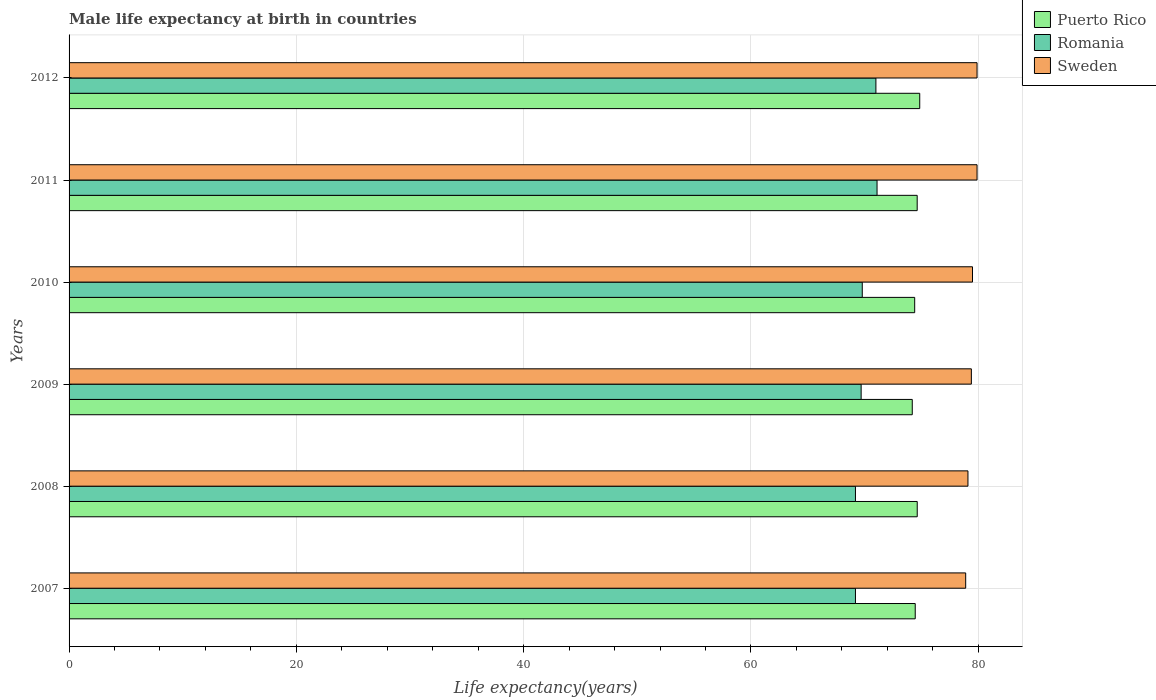In how many cases, is the number of bars for a given year not equal to the number of legend labels?
Make the answer very short. 0. What is the male life expectancy at birth in Puerto Rico in 2009?
Your response must be concise. 74.2. Across all years, what is the maximum male life expectancy at birth in Puerto Rico?
Your response must be concise. 74.86. Across all years, what is the minimum male life expectancy at birth in Sweden?
Your answer should be very brief. 78.9. In which year was the male life expectancy at birth in Romania minimum?
Provide a succinct answer. 2007. What is the total male life expectancy at birth in Puerto Rico in the graph?
Provide a short and direct response. 447.2. What is the difference between the male life expectancy at birth in Puerto Rico in 2009 and that in 2010?
Offer a very short reply. -0.21. What is the difference between the male life expectancy at birth in Puerto Rico in 2009 and the male life expectancy at birth in Sweden in 2012?
Offer a terse response. -5.7. What is the average male life expectancy at birth in Puerto Rico per year?
Your answer should be very brief. 74.53. In the year 2012, what is the difference between the male life expectancy at birth in Romania and male life expectancy at birth in Puerto Rico?
Your answer should be compact. -3.86. In how many years, is the male life expectancy at birth in Sweden greater than 48 years?
Provide a short and direct response. 6. What is the ratio of the male life expectancy at birth in Romania in 2007 to that in 2012?
Offer a very short reply. 0.97. What is the difference between the highest and the second highest male life expectancy at birth in Romania?
Your answer should be very brief. 0.1. What is the difference between the highest and the lowest male life expectancy at birth in Romania?
Give a very brief answer. 1.9. In how many years, is the male life expectancy at birth in Puerto Rico greater than the average male life expectancy at birth in Puerto Rico taken over all years?
Your answer should be compact. 3. What does the 3rd bar from the top in 2008 represents?
Offer a very short reply. Puerto Rico. What does the 1st bar from the bottom in 2011 represents?
Keep it short and to the point. Puerto Rico. Are all the bars in the graph horizontal?
Your answer should be very brief. Yes. How many years are there in the graph?
Your answer should be very brief. 6. What is the difference between two consecutive major ticks on the X-axis?
Your answer should be compact. 20. Does the graph contain any zero values?
Provide a succinct answer. No. Does the graph contain grids?
Offer a very short reply. Yes. How many legend labels are there?
Provide a short and direct response. 3. What is the title of the graph?
Your response must be concise. Male life expectancy at birth in countries. Does "Panama" appear as one of the legend labels in the graph?
Ensure brevity in your answer.  No. What is the label or title of the X-axis?
Provide a succinct answer. Life expectancy(years). What is the Life expectancy(years) of Puerto Rico in 2007?
Offer a very short reply. 74.46. What is the Life expectancy(years) of Romania in 2007?
Your answer should be compact. 69.2. What is the Life expectancy(years) in Sweden in 2007?
Make the answer very short. 78.9. What is the Life expectancy(years) in Puerto Rico in 2008?
Offer a terse response. 74.64. What is the Life expectancy(years) of Romania in 2008?
Offer a terse response. 69.2. What is the Life expectancy(years) in Sweden in 2008?
Make the answer very short. 79.1. What is the Life expectancy(years) in Puerto Rico in 2009?
Give a very brief answer. 74.2. What is the Life expectancy(years) in Romania in 2009?
Ensure brevity in your answer.  69.7. What is the Life expectancy(years) in Sweden in 2009?
Provide a short and direct response. 79.4. What is the Life expectancy(years) of Puerto Rico in 2010?
Provide a succinct answer. 74.41. What is the Life expectancy(years) in Romania in 2010?
Keep it short and to the point. 69.8. What is the Life expectancy(years) of Sweden in 2010?
Offer a very short reply. 79.5. What is the Life expectancy(years) in Puerto Rico in 2011?
Your response must be concise. 74.63. What is the Life expectancy(years) in Romania in 2011?
Your answer should be compact. 71.1. What is the Life expectancy(years) in Sweden in 2011?
Your response must be concise. 79.9. What is the Life expectancy(years) in Puerto Rico in 2012?
Provide a succinct answer. 74.86. What is the Life expectancy(years) of Sweden in 2012?
Your response must be concise. 79.9. Across all years, what is the maximum Life expectancy(years) in Puerto Rico?
Your answer should be very brief. 74.86. Across all years, what is the maximum Life expectancy(years) in Romania?
Your response must be concise. 71.1. Across all years, what is the maximum Life expectancy(years) of Sweden?
Your answer should be very brief. 79.9. Across all years, what is the minimum Life expectancy(years) of Puerto Rico?
Offer a terse response. 74.2. Across all years, what is the minimum Life expectancy(years) in Romania?
Offer a terse response. 69.2. Across all years, what is the minimum Life expectancy(years) of Sweden?
Make the answer very short. 78.9. What is the total Life expectancy(years) of Puerto Rico in the graph?
Your response must be concise. 447.2. What is the total Life expectancy(years) in Romania in the graph?
Provide a succinct answer. 420. What is the total Life expectancy(years) in Sweden in the graph?
Your answer should be compact. 476.7. What is the difference between the Life expectancy(years) in Puerto Rico in 2007 and that in 2008?
Give a very brief answer. -0.18. What is the difference between the Life expectancy(years) of Sweden in 2007 and that in 2008?
Your answer should be very brief. -0.2. What is the difference between the Life expectancy(years) of Puerto Rico in 2007 and that in 2009?
Keep it short and to the point. 0.26. What is the difference between the Life expectancy(years) in Romania in 2007 and that in 2009?
Your answer should be very brief. -0.5. What is the difference between the Life expectancy(years) in Sweden in 2007 and that in 2009?
Your answer should be very brief. -0.5. What is the difference between the Life expectancy(years) in Puerto Rico in 2007 and that in 2010?
Provide a succinct answer. 0.05. What is the difference between the Life expectancy(years) of Romania in 2007 and that in 2010?
Give a very brief answer. -0.6. What is the difference between the Life expectancy(years) in Puerto Rico in 2007 and that in 2011?
Offer a terse response. -0.17. What is the difference between the Life expectancy(years) in Sweden in 2007 and that in 2011?
Make the answer very short. -1. What is the difference between the Life expectancy(years) in Puerto Rico in 2007 and that in 2012?
Your response must be concise. -0.4. What is the difference between the Life expectancy(years) in Sweden in 2007 and that in 2012?
Give a very brief answer. -1. What is the difference between the Life expectancy(years) in Puerto Rico in 2008 and that in 2009?
Ensure brevity in your answer.  0.44. What is the difference between the Life expectancy(years) of Sweden in 2008 and that in 2009?
Your response must be concise. -0.3. What is the difference between the Life expectancy(years) of Puerto Rico in 2008 and that in 2010?
Your answer should be compact. 0.22. What is the difference between the Life expectancy(years) of Romania in 2008 and that in 2010?
Give a very brief answer. -0.6. What is the difference between the Life expectancy(years) of Sweden in 2008 and that in 2010?
Give a very brief answer. -0.4. What is the difference between the Life expectancy(years) of Puerto Rico in 2008 and that in 2011?
Ensure brevity in your answer.  0. What is the difference between the Life expectancy(years) in Puerto Rico in 2008 and that in 2012?
Ensure brevity in your answer.  -0.22. What is the difference between the Life expectancy(years) in Romania in 2008 and that in 2012?
Make the answer very short. -1.8. What is the difference between the Life expectancy(years) of Sweden in 2008 and that in 2012?
Offer a terse response. -0.8. What is the difference between the Life expectancy(years) in Puerto Rico in 2009 and that in 2010?
Offer a very short reply. -0.21. What is the difference between the Life expectancy(years) of Puerto Rico in 2009 and that in 2011?
Your answer should be compact. -0.43. What is the difference between the Life expectancy(years) in Sweden in 2009 and that in 2011?
Provide a succinct answer. -0.5. What is the difference between the Life expectancy(years) in Puerto Rico in 2009 and that in 2012?
Ensure brevity in your answer.  -0.66. What is the difference between the Life expectancy(years) of Romania in 2009 and that in 2012?
Provide a succinct answer. -1.3. What is the difference between the Life expectancy(years) of Sweden in 2009 and that in 2012?
Your response must be concise. -0.5. What is the difference between the Life expectancy(years) in Puerto Rico in 2010 and that in 2011?
Offer a terse response. -0.22. What is the difference between the Life expectancy(years) in Romania in 2010 and that in 2011?
Make the answer very short. -1.3. What is the difference between the Life expectancy(years) of Sweden in 2010 and that in 2011?
Ensure brevity in your answer.  -0.4. What is the difference between the Life expectancy(years) of Puerto Rico in 2010 and that in 2012?
Provide a short and direct response. -0.45. What is the difference between the Life expectancy(years) of Romania in 2010 and that in 2012?
Keep it short and to the point. -1.2. What is the difference between the Life expectancy(years) of Puerto Rico in 2011 and that in 2012?
Ensure brevity in your answer.  -0.22. What is the difference between the Life expectancy(years) of Romania in 2011 and that in 2012?
Your answer should be compact. 0.1. What is the difference between the Life expectancy(years) in Puerto Rico in 2007 and the Life expectancy(years) in Romania in 2008?
Keep it short and to the point. 5.26. What is the difference between the Life expectancy(years) of Puerto Rico in 2007 and the Life expectancy(years) of Sweden in 2008?
Provide a succinct answer. -4.64. What is the difference between the Life expectancy(years) in Puerto Rico in 2007 and the Life expectancy(years) in Romania in 2009?
Give a very brief answer. 4.76. What is the difference between the Life expectancy(years) in Puerto Rico in 2007 and the Life expectancy(years) in Sweden in 2009?
Your answer should be compact. -4.94. What is the difference between the Life expectancy(years) in Puerto Rico in 2007 and the Life expectancy(years) in Romania in 2010?
Offer a very short reply. 4.66. What is the difference between the Life expectancy(years) of Puerto Rico in 2007 and the Life expectancy(years) of Sweden in 2010?
Offer a terse response. -5.04. What is the difference between the Life expectancy(years) in Puerto Rico in 2007 and the Life expectancy(years) in Romania in 2011?
Offer a terse response. 3.36. What is the difference between the Life expectancy(years) in Puerto Rico in 2007 and the Life expectancy(years) in Sweden in 2011?
Give a very brief answer. -5.44. What is the difference between the Life expectancy(years) in Romania in 2007 and the Life expectancy(years) in Sweden in 2011?
Offer a very short reply. -10.7. What is the difference between the Life expectancy(years) in Puerto Rico in 2007 and the Life expectancy(years) in Romania in 2012?
Your answer should be very brief. 3.46. What is the difference between the Life expectancy(years) of Puerto Rico in 2007 and the Life expectancy(years) of Sweden in 2012?
Ensure brevity in your answer.  -5.44. What is the difference between the Life expectancy(years) of Puerto Rico in 2008 and the Life expectancy(years) of Romania in 2009?
Give a very brief answer. 4.94. What is the difference between the Life expectancy(years) in Puerto Rico in 2008 and the Life expectancy(years) in Sweden in 2009?
Offer a very short reply. -4.76. What is the difference between the Life expectancy(years) of Romania in 2008 and the Life expectancy(years) of Sweden in 2009?
Give a very brief answer. -10.2. What is the difference between the Life expectancy(years) in Puerto Rico in 2008 and the Life expectancy(years) in Romania in 2010?
Your answer should be very brief. 4.84. What is the difference between the Life expectancy(years) in Puerto Rico in 2008 and the Life expectancy(years) in Sweden in 2010?
Offer a terse response. -4.86. What is the difference between the Life expectancy(years) in Puerto Rico in 2008 and the Life expectancy(years) in Romania in 2011?
Ensure brevity in your answer.  3.54. What is the difference between the Life expectancy(years) of Puerto Rico in 2008 and the Life expectancy(years) of Sweden in 2011?
Your answer should be compact. -5.26. What is the difference between the Life expectancy(years) of Puerto Rico in 2008 and the Life expectancy(years) of Romania in 2012?
Your response must be concise. 3.64. What is the difference between the Life expectancy(years) of Puerto Rico in 2008 and the Life expectancy(years) of Sweden in 2012?
Your response must be concise. -5.26. What is the difference between the Life expectancy(years) of Romania in 2008 and the Life expectancy(years) of Sweden in 2012?
Provide a succinct answer. -10.7. What is the difference between the Life expectancy(years) of Puerto Rico in 2009 and the Life expectancy(years) of Romania in 2010?
Provide a succinct answer. 4.4. What is the difference between the Life expectancy(years) in Puerto Rico in 2009 and the Life expectancy(years) in Sweden in 2010?
Offer a very short reply. -5.3. What is the difference between the Life expectancy(years) of Romania in 2009 and the Life expectancy(years) of Sweden in 2010?
Your answer should be compact. -9.8. What is the difference between the Life expectancy(years) of Puerto Rico in 2009 and the Life expectancy(years) of Romania in 2011?
Offer a very short reply. 3.1. What is the difference between the Life expectancy(years) in Puerto Rico in 2009 and the Life expectancy(years) in Sweden in 2011?
Ensure brevity in your answer.  -5.7. What is the difference between the Life expectancy(years) in Romania in 2009 and the Life expectancy(years) in Sweden in 2011?
Give a very brief answer. -10.2. What is the difference between the Life expectancy(years) in Puerto Rico in 2009 and the Life expectancy(years) in Romania in 2012?
Provide a succinct answer. 3.2. What is the difference between the Life expectancy(years) of Puerto Rico in 2009 and the Life expectancy(years) of Sweden in 2012?
Make the answer very short. -5.7. What is the difference between the Life expectancy(years) in Puerto Rico in 2010 and the Life expectancy(years) in Romania in 2011?
Your answer should be very brief. 3.31. What is the difference between the Life expectancy(years) of Puerto Rico in 2010 and the Life expectancy(years) of Sweden in 2011?
Ensure brevity in your answer.  -5.49. What is the difference between the Life expectancy(years) of Romania in 2010 and the Life expectancy(years) of Sweden in 2011?
Offer a terse response. -10.1. What is the difference between the Life expectancy(years) of Puerto Rico in 2010 and the Life expectancy(years) of Romania in 2012?
Make the answer very short. 3.41. What is the difference between the Life expectancy(years) of Puerto Rico in 2010 and the Life expectancy(years) of Sweden in 2012?
Ensure brevity in your answer.  -5.49. What is the difference between the Life expectancy(years) of Puerto Rico in 2011 and the Life expectancy(years) of Romania in 2012?
Offer a terse response. 3.63. What is the difference between the Life expectancy(years) of Puerto Rico in 2011 and the Life expectancy(years) of Sweden in 2012?
Offer a very short reply. -5.27. What is the average Life expectancy(years) in Puerto Rico per year?
Provide a short and direct response. 74.53. What is the average Life expectancy(years) of Romania per year?
Offer a terse response. 70. What is the average Life expectancy(years) in Sweden per year?
Offer a very short reply. 79.45. In the year 2007, what is the difference between the Life expectancy(years) of Puerto Rico and Life expectancy(years) of Romania?
Keep it short and to the point. 5.26. In the year 2007, what is the difference between the Life expectancy(years) of Puerto Rico and Life expectancy(years) of Sweden?
Your answer should be very brief. -4.44. In the year 2008, what is the difference between the Life expectancy(years) of Puerto Rico and Life expectancy(years) of Romania?
Keep it short and to the point. 5.44. In the year 2008, what is the difference between the Life expectancy(years) in Puerto Rico and Life expectancy(years) in Sweden?
Provide a short and direct response. -4.46. In the year 2009, what is the difference between the Life expectancy(years) of Puerto Rico and Life expectancy(years) of Romania?
Your response must be concise. 4.5. In the year 2009, what is the difference between the Life expectancy(years) in Puerto Rico and Life expectancy(years) in Sweden?
Make the answer very short. -5.2. In the year 2010, what is the difference between the Life expectancy(years) in Puerto Rico and Life expectancy(years) in Romania?
Keep it short and to the point. 4.61. In the year 2010, what is the difference between the Life expectancy(years) in Puerto Rico and Life expectancy(years) in Sweden?
Provide a short and direct response. -5.09. In the year 2010, what is the difference between the Life expectancy(years) in Romania and Life expectancy(years) in Sweden?
Your answer should be compact. -9.7. In the year 2011, what is the difference between the Life expectancy(years) of Puerto Rico and Life expectancy(years) of Romania?
Your answer should be compact. 3.53. In the year 2011, what is the difference between the Life expectancy(years) of Puerto Rico and Life expectancy(years) of Sweden?
Make the answer very short. -5.27. In the year 2012, what is the difference between the Life expectancy(years) of Puerto Rico and Life expectancy(years) of Romania?
Your answer should be very brief. 3.86. In the year 2012, what is the difference between the Life expectancy(years) of Puerto Rico and Life expectancy(years) of Sweden?
Your response must be concise. -5.04. What is the ratio of the Life expectancy(years) in Puerto Rico in 2007 to that in 2008?
Provide a succinct answer. 1. What is the ratio of the Life expectancy(years) in Sweden in 2007 to that in 2008?
Keep it short and to the point. 1. What is the ratio of the Life expectancy(years) of Puerto Rico in 2007 to that in 2010?
Provide a short and direct response. 1. What is the ratio of the Life expectancy(years) in Puerto Rico in 2007 to that in 2011?
Keep it short and to the point. 1. What is the ratio of the Life expectancy(years) of Romania in 2007 to that in 2011?
Provide a succinct answer. 0.97. What is the ratio of the Life expectancy(years) in Sweden in 2007 to that in 2011?
Keep it short and to the point. 0.99. What is the ratio of the Life expectancy(years) of Puerto Rico in 2007 to that in 2012?
Make the answer very short. 0.99. What is the ratio of the Life expectancy(years) of Romania in 2007 to that in 2012?
Ensure brevity in your answer.  0.97. What is the ratio of the Life expectancy(years) of Sweden in 2007 to that in 2012?
Ensure brevity in your answer.  0.99. What is the ratio of the Life expectancy(years) of Puerto Rico in 2008 to that in 2009?
Give a very brief answer. 1.01. What is the ratio of the Life expectancy(years) in Romania in 2008 to that in 2009?
Your response must be concise. 0.99. What is the ratio of the Life expectancy(years) in Sweden in 2008 to that in 2009?
Give a very brief answer. 1. What is the ratio of the Life expectancy(years) in Romania in 2008 to that in 2010?
Your answer should be compact. 0.99. What is the ratio of the Life expectancy(years) in Romania in 2008 to that in 2011?
Provide a succinct answer. 0.97. What is the ratio of the Life expectancy(years) in Sweden in 2008 to that in 2011?
Provide a short and direct response. 0.99. What is the ratio of the Life expectancy(years) of Puerto Rico in 2008 to that in 2012?
Provide a succinct answer. 1. What is the ratio of the Life expectancy(years) in Romania in 2008 to that in 2012?
Your answer should be compact. 0.97. What is the ratio of the Life expectancy(years) of Romania in 2009 to that in 2011?
Your response must be concise. 0.98. What is the ratio of the Life expectancy(years) of Sweden in 2009 to that in 2011?
Offer a terse response. 0.99. What is the ratio of the Life expectancy(years) in Puerto Rico in 2009 to that in 2012?
Give a very brief answer. 0.99. What is the ratio of the Life expectancy(years) of Romania in 2009 to that in 2012?
Provide a succinct answer. 0.98. What is the ratio of the Life expectancy(years) of Puerto Rico in 2010 to that in 2011?
Offer a terse response. 1. What is the ratio of the Life expectancy(years) in Romania in 2010 to that in 2011?
Give a very brief answer. 0.98. What is the ratio of the Life expectancy(years) of Sweden in 2010 to that in 2011?
Offer a very short reply. 0.99. What is the ratio of the Life expectancy(years) of Puerto Rico in 2010 to that in 2012?
Keep it short and to the point. 0.99. What is the ratio of the Life expectancy(years) of Romania in 2010 to that in 2012?
Ensure brevity in your answer.  0.98. What is the ratio of the Life expectancy(years) in Puerto Rico in 2011 to that in 2012?
Keep it short and to the point. 1. What is the ratio of the Life expectancy(years) of Romania in 2011 to that in 2012?
Your answer should be very brief. 1. What is the difference between the highest and the second highest Life expectancy(years) of Puerto Rico?
Provide a succinct answer. 0.22. What is the difference between the highest and the lowest Life expectancy(years) of Puerto Rico?
Provide a short and direct response. 0.66. What is the difference between the highest and the lowest Life expectancy(years) in Romania?
Provide a succinct answer. 1.9. 